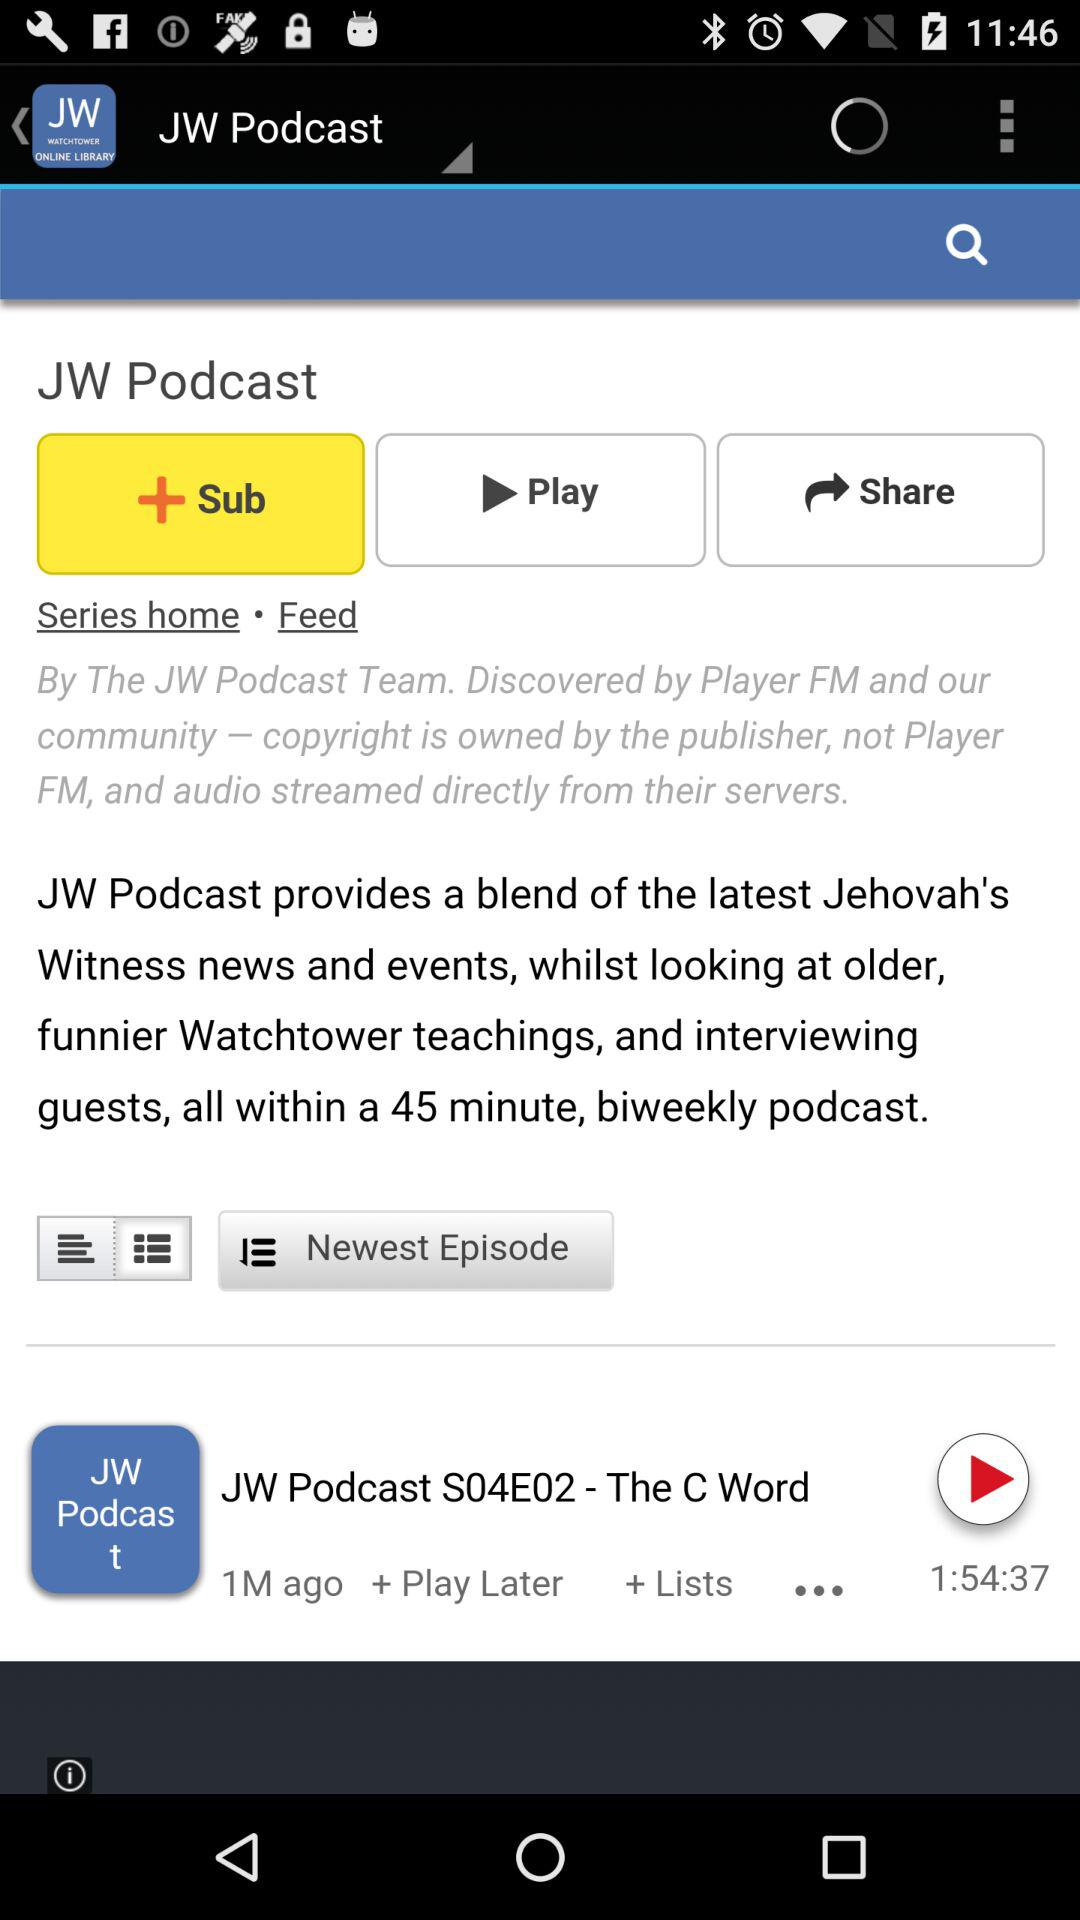What is the publication time? The publication time was 1 month ago. 